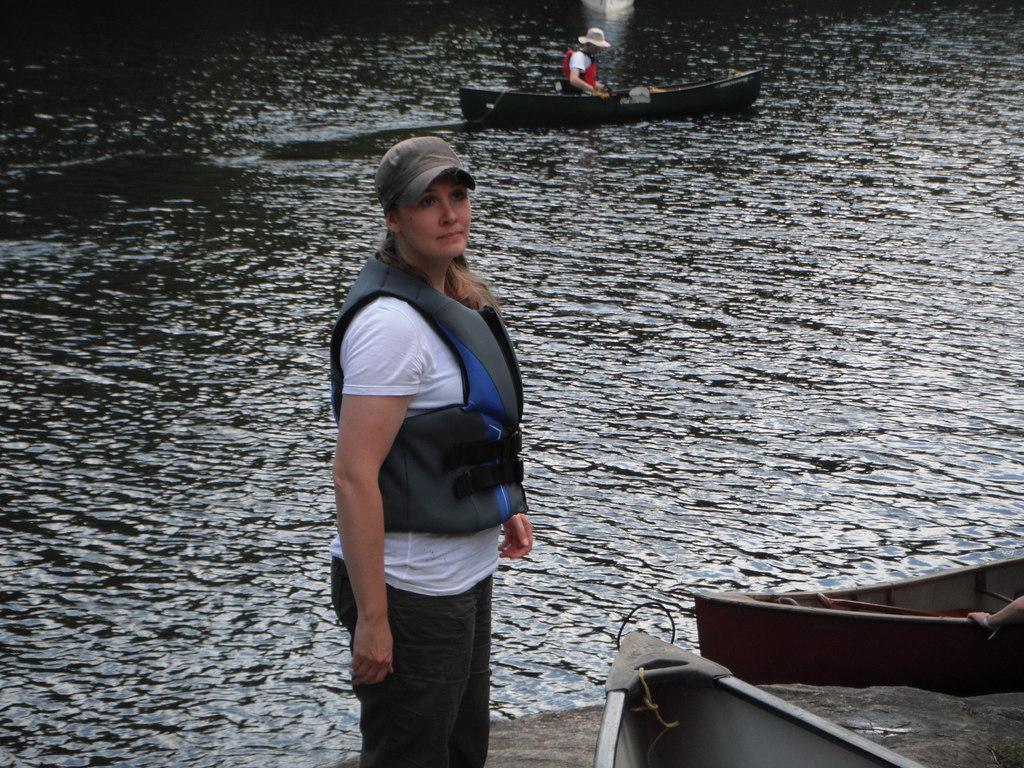Could you give a brief overview of what you see in this image? In the middle of the image, there is a woman in white color t-shirt, wearing a cap and standing. Beside her, there is a boat. On the right side, there is a boat. Beside this, there is a platform. In the background, there is a person sitting on a boat which is on the water. 